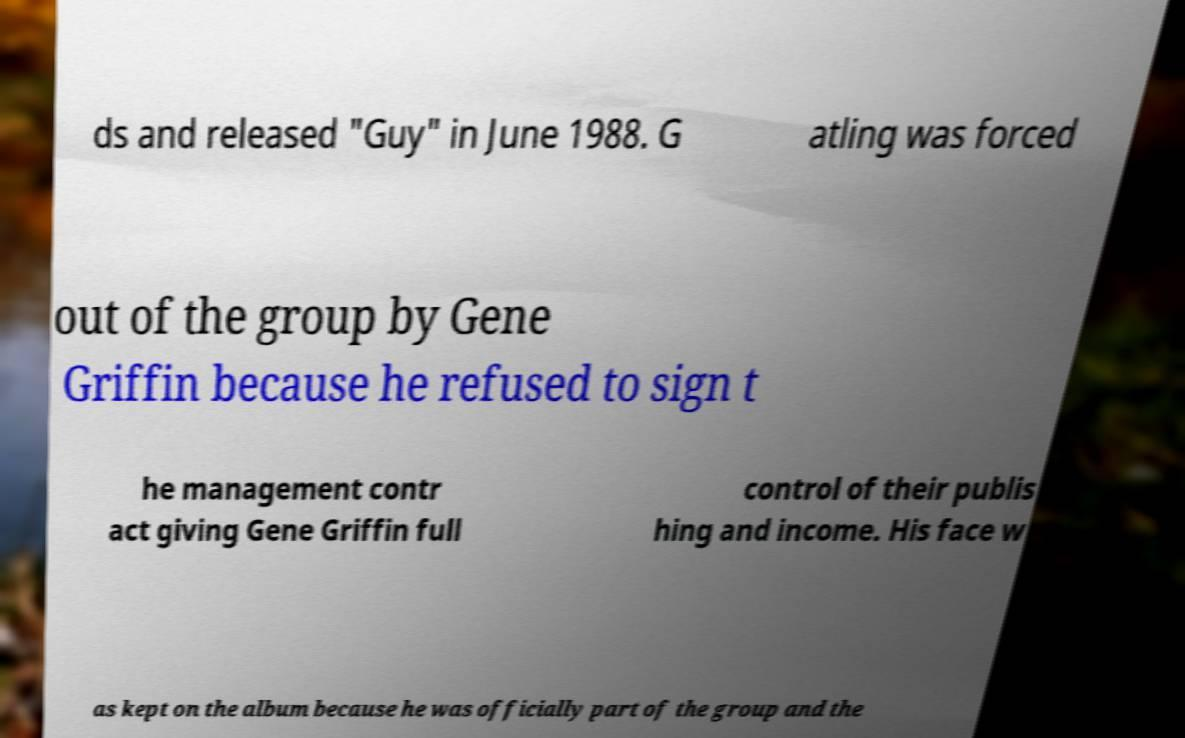What messages or text are displayed in this image? I need them in a readable, typed format. ds and released "Guy" in June 1988. G atling was forced out of the group by Gene Griffin because he refused to sign t he management contr act giving Gene Griffin full control of their publis hing and income. His face w as kept on the album because he was officially part of the group and the 